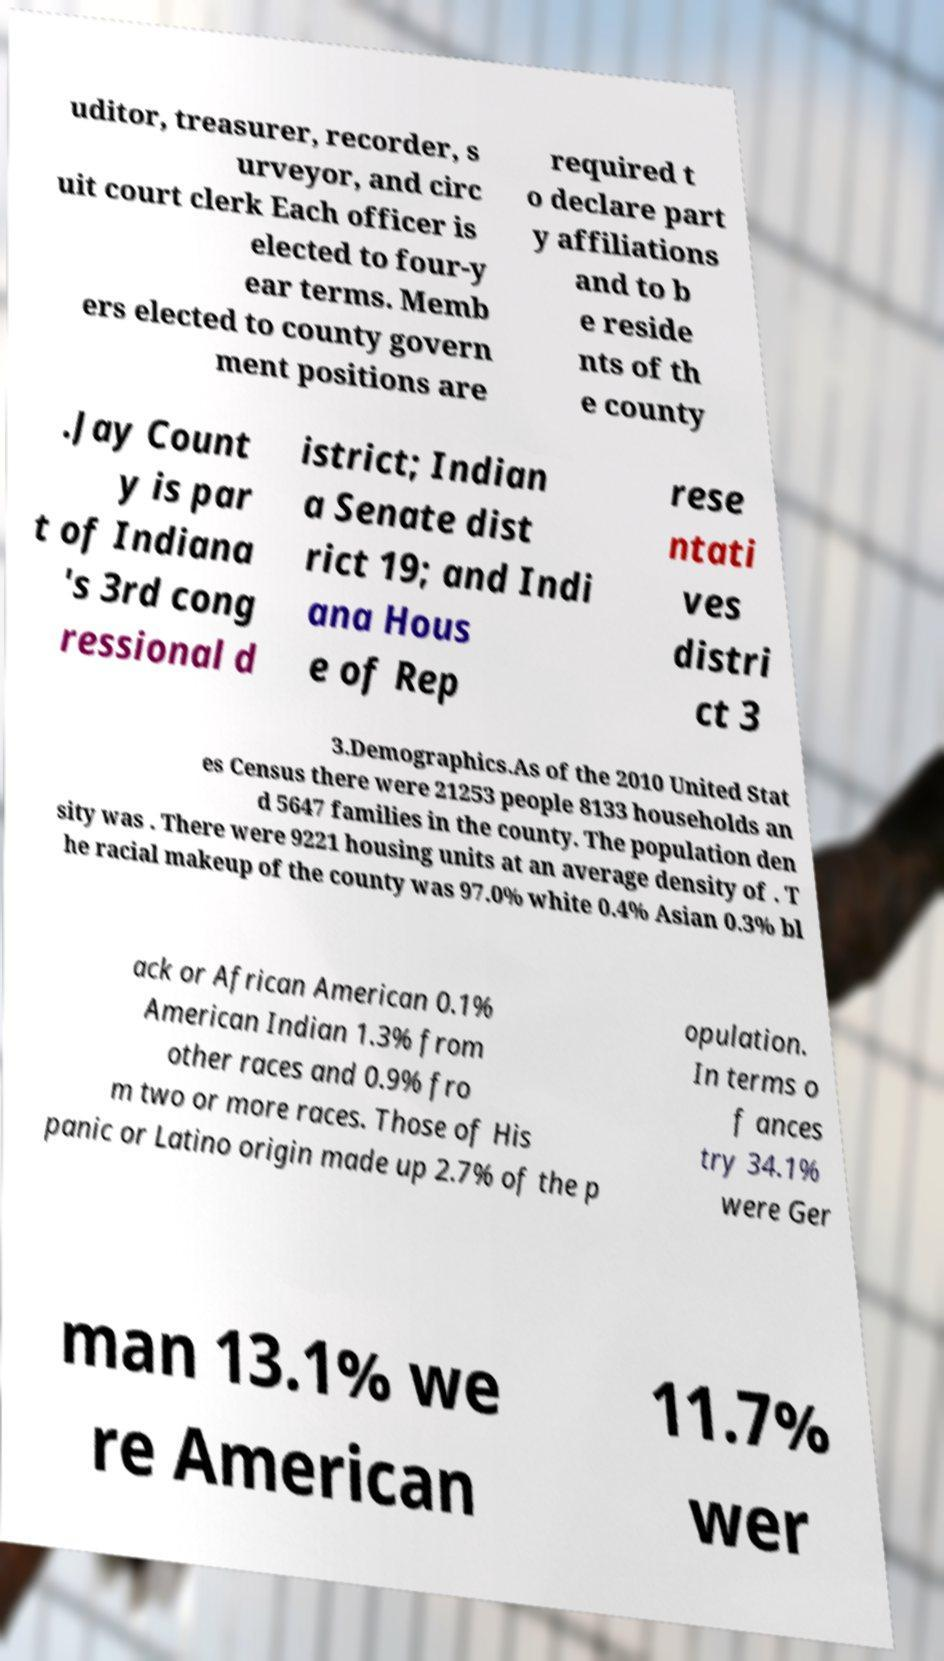Please read and relay the text visible in this image. What does it say? uditor, treasurer, recorder, s urveyor, and circ uit court clerk Each officer is elected to four-y ear terms. Memb ers elected to county govern ment positions are required t o declare part y affiliations and to b e reside nts of th e county .Jay Count y is par t of Indiana 's 3rd cong ressional d istrict; Indian a Senate dist rict 19; and Indi ana Hous e of Rep rese ntati ves distri ct 3 3.Demographics.As of the 2010 United Stat es Census there were 21253 people 8133 households an d 5647 families in the county. The population den sity was . There were 9221 housing units at an average density of . T he racial makeup of the county was 97.0% white 0.4% Asian 0.3% bl ack or African American 0.1% American Indian 1.3% from other races and 0.9% fro m two or more races. Those of His panic or Latino origin made up 2.7% of the p opulation. In terms o f ances try 34.1% were Ger man 13.1% we re American 11.7% wer 